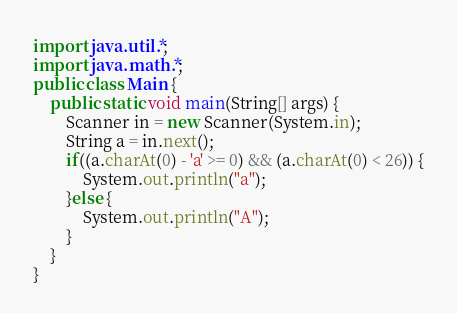<code> <loc_0><loc_0><loc_500><loc_500><_Java_>import java.util.*;
import java.math.*;
public class Main {
	public static void main(String[] args) {
		Scanner in = new Scanner(System.in);
		String a = in.next();
		if((a.charAt(0) - 'a' >= 0) && (a.charAt(0) < 26)) {
			System.out.println("a");
		}else {
			System.out.println("A");
		}
	}
}</code> 